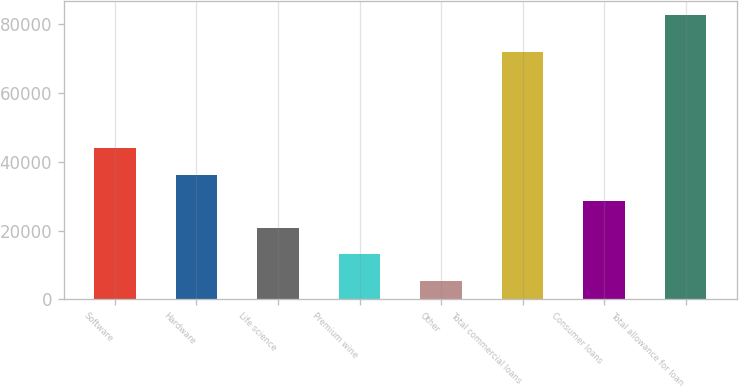Convert chart. <chart><loc_0><loc_0><loc_500><loc_500><bar_chart><fcel>Software<fcel>Hardware<fcel>Life science<fcel>Premium wine<fcel>Other<fcel>Total commercial loans<fcel>Consumer loans<fcel>Total allowance for loan<nl><fcel>43972.5<fcel>36241.6<fcel>20779.8<fcel>13048.9<fcel>5318<fcel>72104<fcel>28510.7<fcel>82627<nl></chart> 